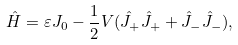<formula> <loc_0><loc_0><loc_500><loc_500>\hat { H } = \varepsilon J _ { 0 } - \frac { 1 } { 2 } V ( \hat { J } _ { + } \hat { J } _ { + } + \hat { J } _ { - } \hat { J } _ { - } ) ,</formula> 